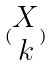Convert formula to latex. <formula><loc_0><loc_0><loc_500><loc_500>( \begin{matrix} X \\ k \end{matrix} )</formula> 